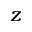Convert formula to latex. <formula><loc_0><loc_0><loc_500><loc_500>z</formula> 